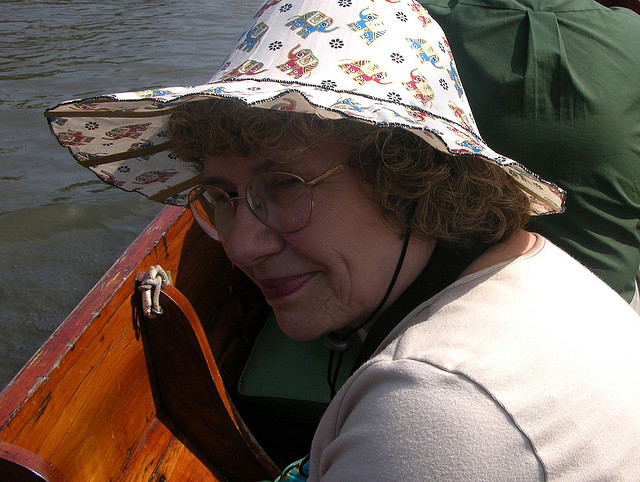<image>Why is she smiling? I don't know why she is smiling. She could be happy, enjoying a boat ride, or heard a joke. Why is she smiling? I don't know why she is smiling. It can be because she heard a joke, she is happy, or she is enjoying her boat ride. 